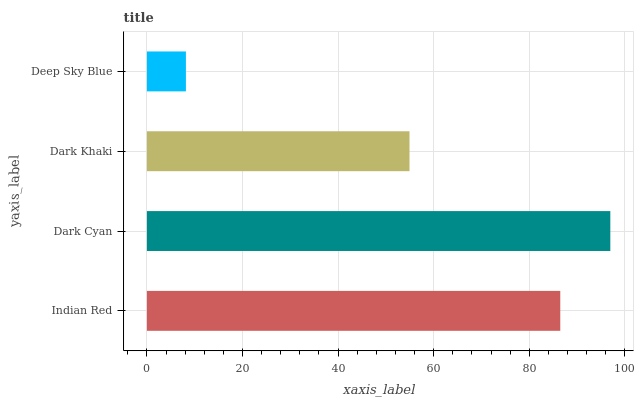Is Deep Sky Blue the minimum?
Answer yes or no. Yes. Is Dark Cyan the maximum?
Answer yes or no. Yes. Is Dark Khaki the minimum?
Answer yes or no. No. Is Dark Khaki the maximum?
Answer yes or no. No. Is Dark Cyan greater than Dark Khaki?
Answer yes or no. Yes. Is Dark Khaki less than Dark Cyan?
Answer yes or no. Yes. Is Dark Khaki greater than Dark Cyan?
Answer yes or no. No. Is Dark Cyan less than Dark Khaki?
Answer yes or no. No. Is Indian Red the high median?
Answer yes or no. Yes. Is Dark Khaki the low median?
Answer yes or no. Yes. Is Dark Khaki the high median?
Answer yes or no. No. Is Indian Red the low median?
Answer yes or no. No. 